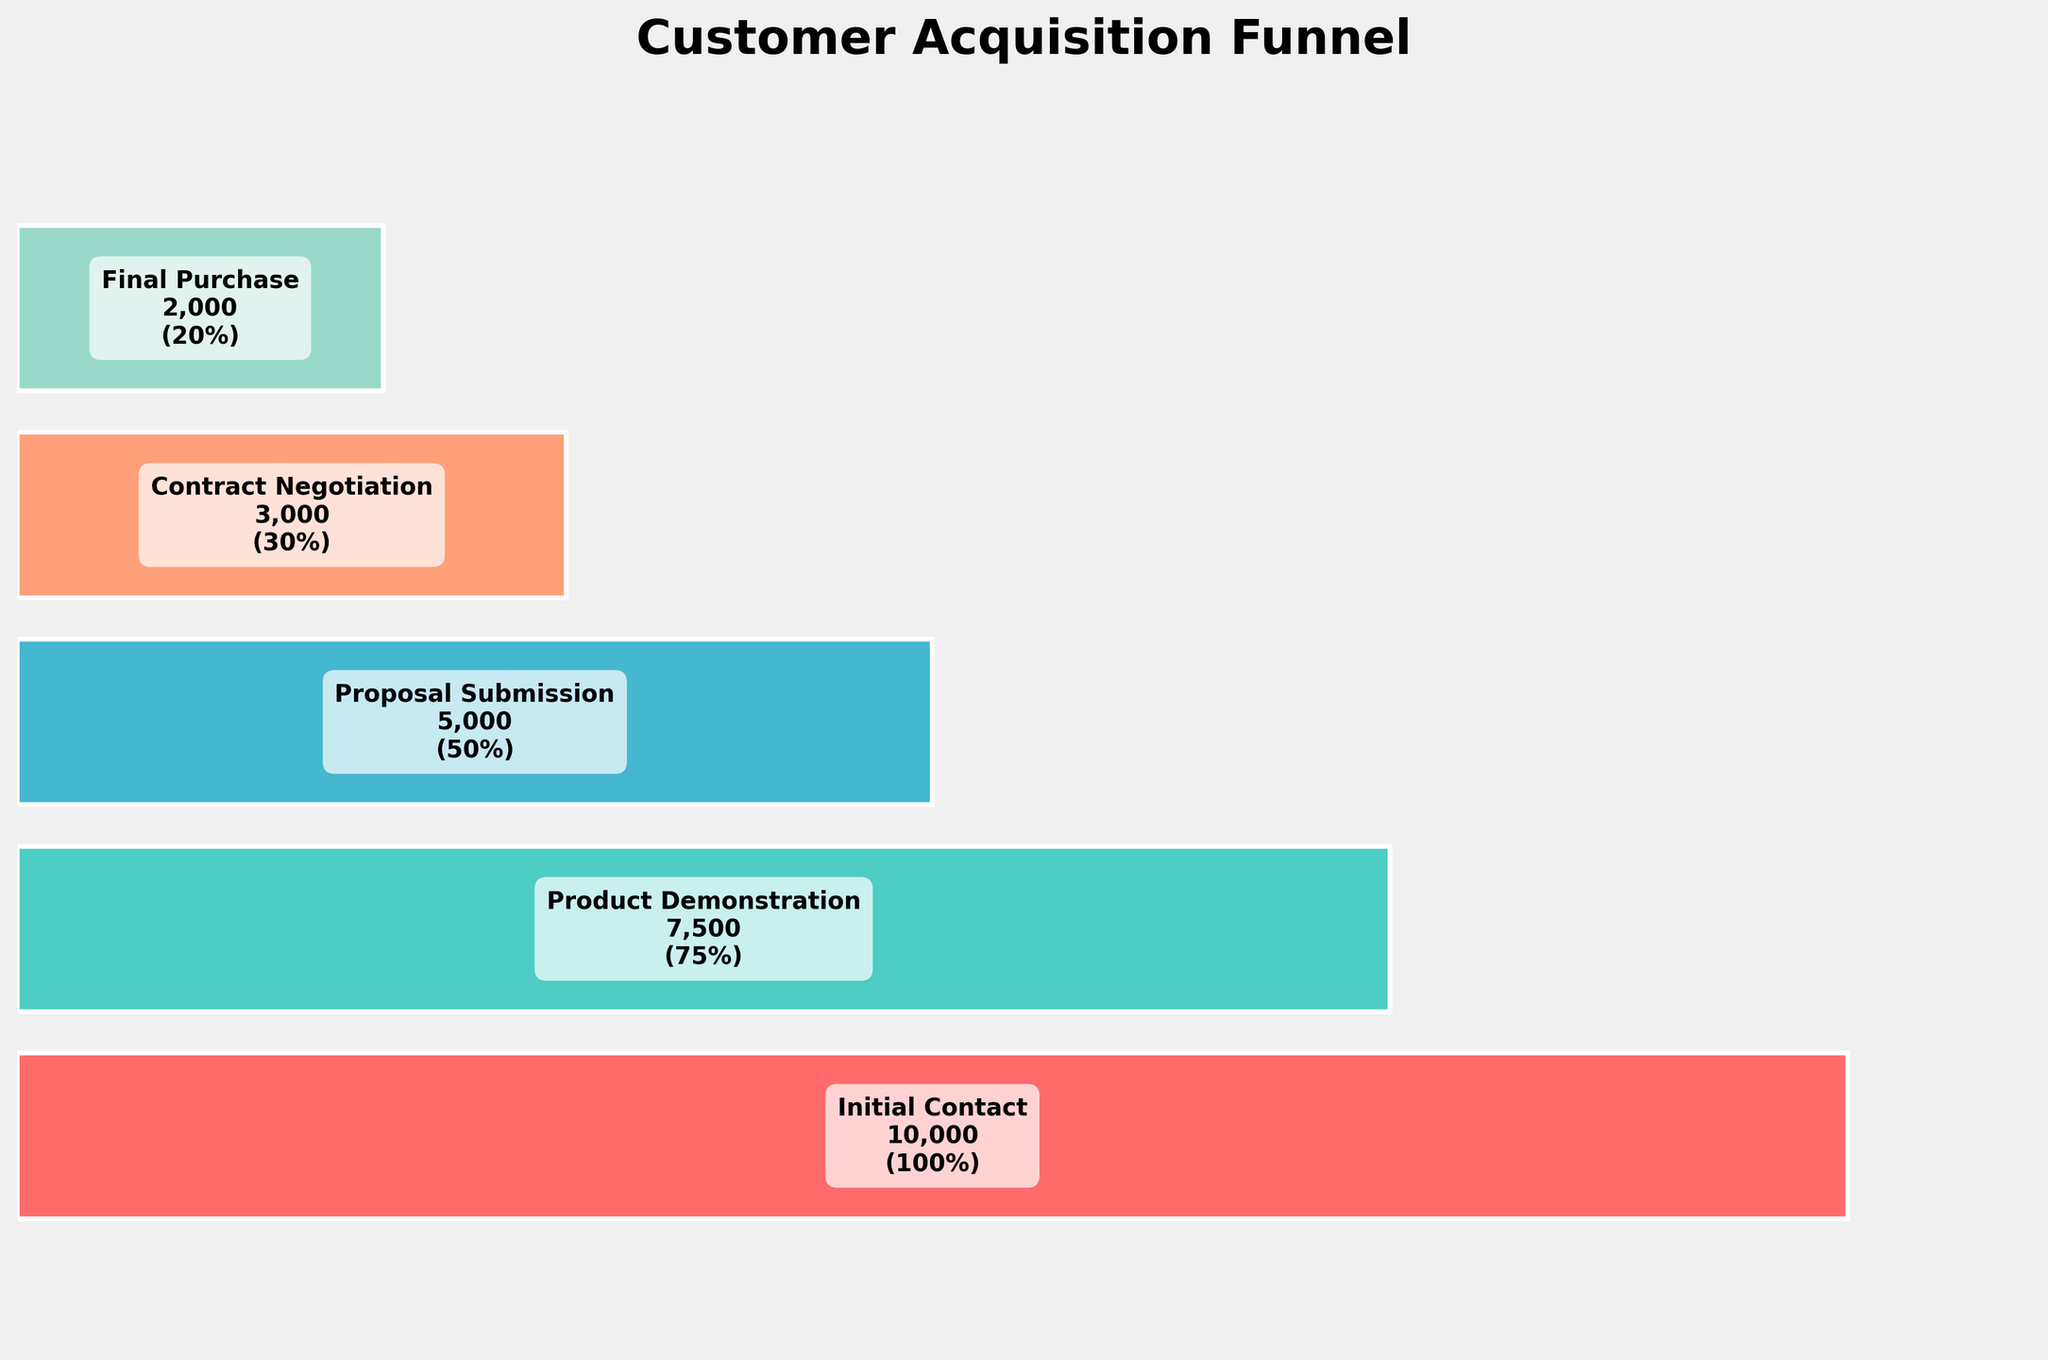How many stages are shown in the funnel chart? Count the distinct levels in the funnel chart. There are five stages listed: Initial Contact, Product Demonstration, Proposal Submission, Contract Negotiation, and Final Purchase.
Answer: Five Which stage sees the largest drop in percentage from the previous stage? Compare the percentage decrements between consecutive stages. The largest drop is from Initial Contact (100%) to Product Demonstration (75%), which is a 25% drop.
Answer: Initial Contact to Product Demonstration What percentage of customers who received a product demonstration eventually make a final purchase? Calculate the ratio of customers making the final purchase (20%) to those who had a product demonstration (75%). The percentage is (20/75) * 100 = 26.67%.
Answer: 26.67% If 10000 prospective customers start at the Initial Contact stage, how many are expected to make a Final Purchase? Use the data to follow through all the stages. 10000 * 0.75 = 7500 make it to Product Demonstration, 7500 * 0.50 = 5000 move to Proposal Submission, 5000 * 0.60 = 3000 proceed to Contract Negotiation, 3000 * 0.6667 = 2000 complete a Final Purchase.
Answer: 2000 What is the ratio of customers who submit a proposal to customers who negotiate a contract? Use the counts for Proposal Submission and Contract Negotiation to find the ratio: 5000 (Proposal Submission) / 3000 (Contract Negotiation) = 5/3.
Answer: 5:3 Which stage has the smallest percentage decrease from the previous stage, and what is that percentage decrease? Compare the percentage decreases between consecutive stages. The smallest decrease is from Proposal Submission (50%) to Contract Negotiation (30%), which is a decrease of 20%.
Answer: Proposal Submission to Contract Negotiation, 20% What is the total number of customers who drop off between the Product Demonstration and the Final Purchase stages? Sum the customer drop-offs between the stages. From Product Demonstration to Proposal Submission: 7500 - 5000 = 2500, from Proposal Submission to Contract Negotiation: 5000 - 3000 = 2000, from Contract Negotiation to Final Purchase: 3000 - 2000 = 1000. Total drop-off = 2500 + 2000 + 1000 = 5500.
Answer: 5500 How does the conversion rate from Contract Negotiation to Final Purchase compare to the conversion rate from Initial Contact to Final Purchase? Calculate both conversion rates as percentages. Contract Negotiation to Final Purchase: (2000 / 3000) * 100 = 66.67%. Initial Contact to Final Purchase: (2000 / 10000) * 100 = 20%.
Answer: 66.67% vs 20% If the company wants to improve the most critical stage in the funnel, which stage should they focus on? Determine the stage with the largest drop-off. The most critical stage is the one where the largest percentage loss occurs, which is from Initial Contact to Product Demonstration (25% drop).
Answer: Initial Contact to Product Demonstration 